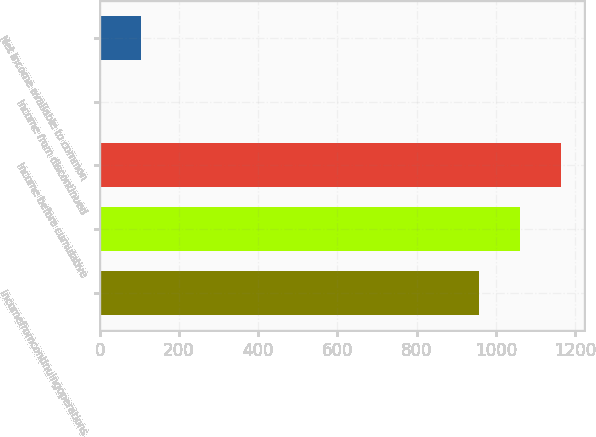Convert chart. <chart><loc_0><loc_0><loc_500><loc_500><bar_chart><fcel>Incomefromcontinuingoperations<fcel>Unnamed: 1<fcel>Income before cumulative<fcel>Income from discontinued<fcel>Net income available to common<nl><fcel>957<fcel>1060.29<fcel>1163.58<fcel>0.1<fcel>103.39<nl></chart> 